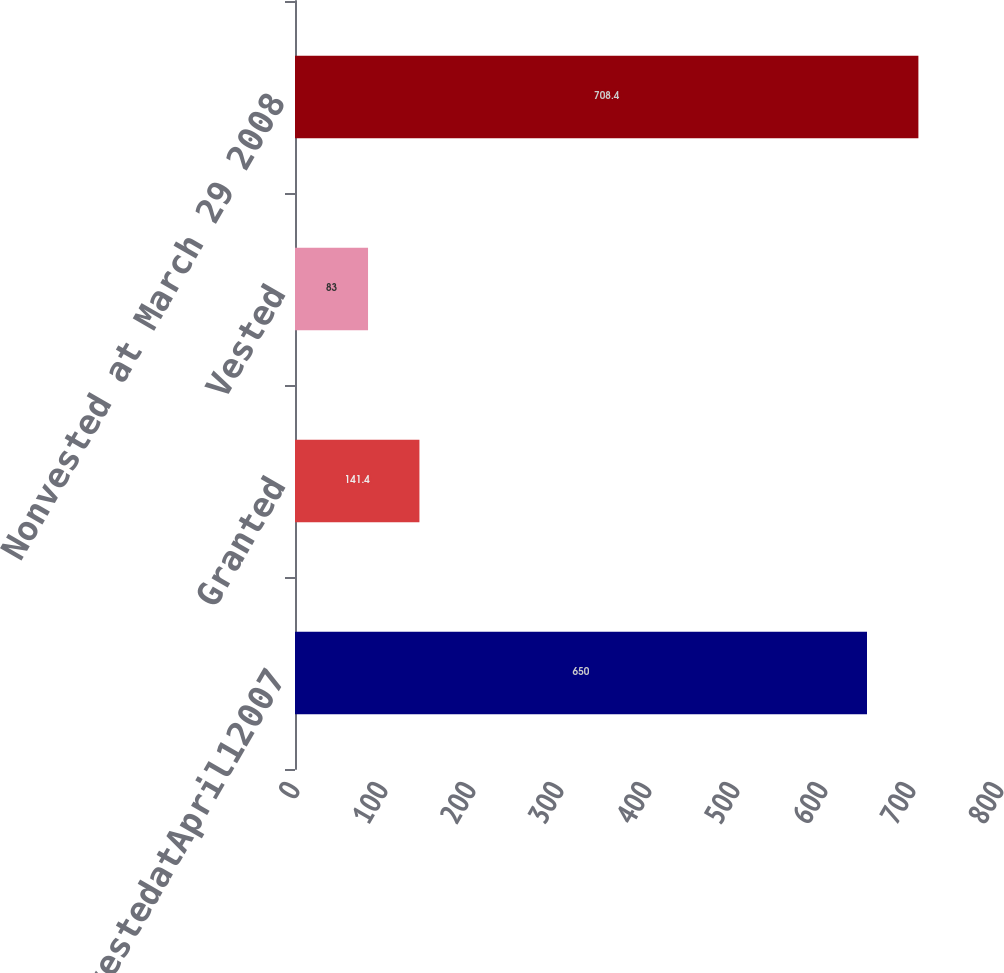Convert chart to OTSL. <chart><loc_0><loc_0><loc_500><loc_500><bar_chart><fcel>NonvestedatApril12007<fcel>Granted<fcel>Vested<fcel>Nonvested at March 29 2008<nl><fcel>650<fcel>141.4<fcel>83<fcel>708.4<nl></chart> 